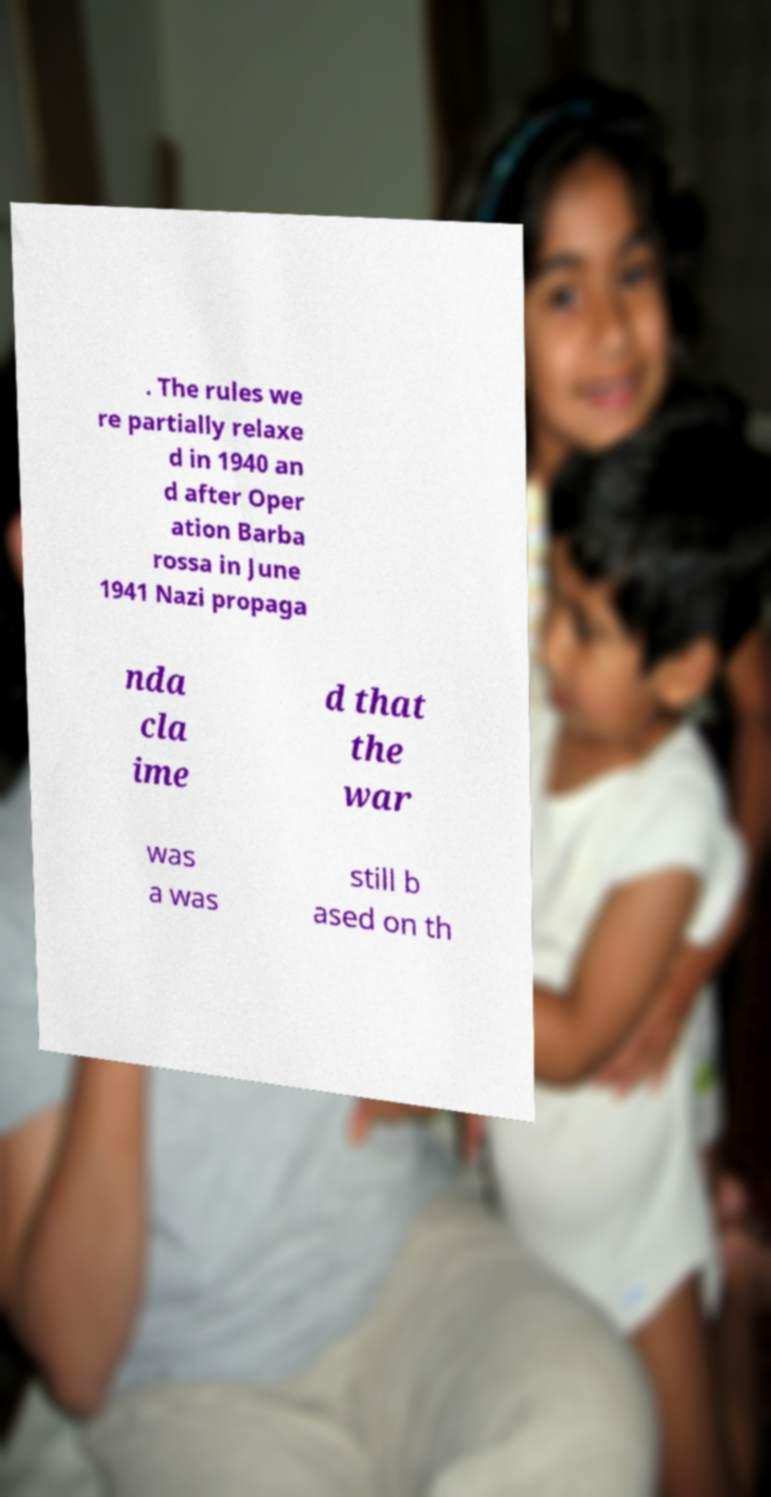What messages or text are displayed in this image? I need them in a readable, typed format. . The rules we re partially relaxe d in 1940 an d after Oper ation Barba rossa in June 1941 Nazi propaga nda cla ime d that the war was a was still b ased on th 